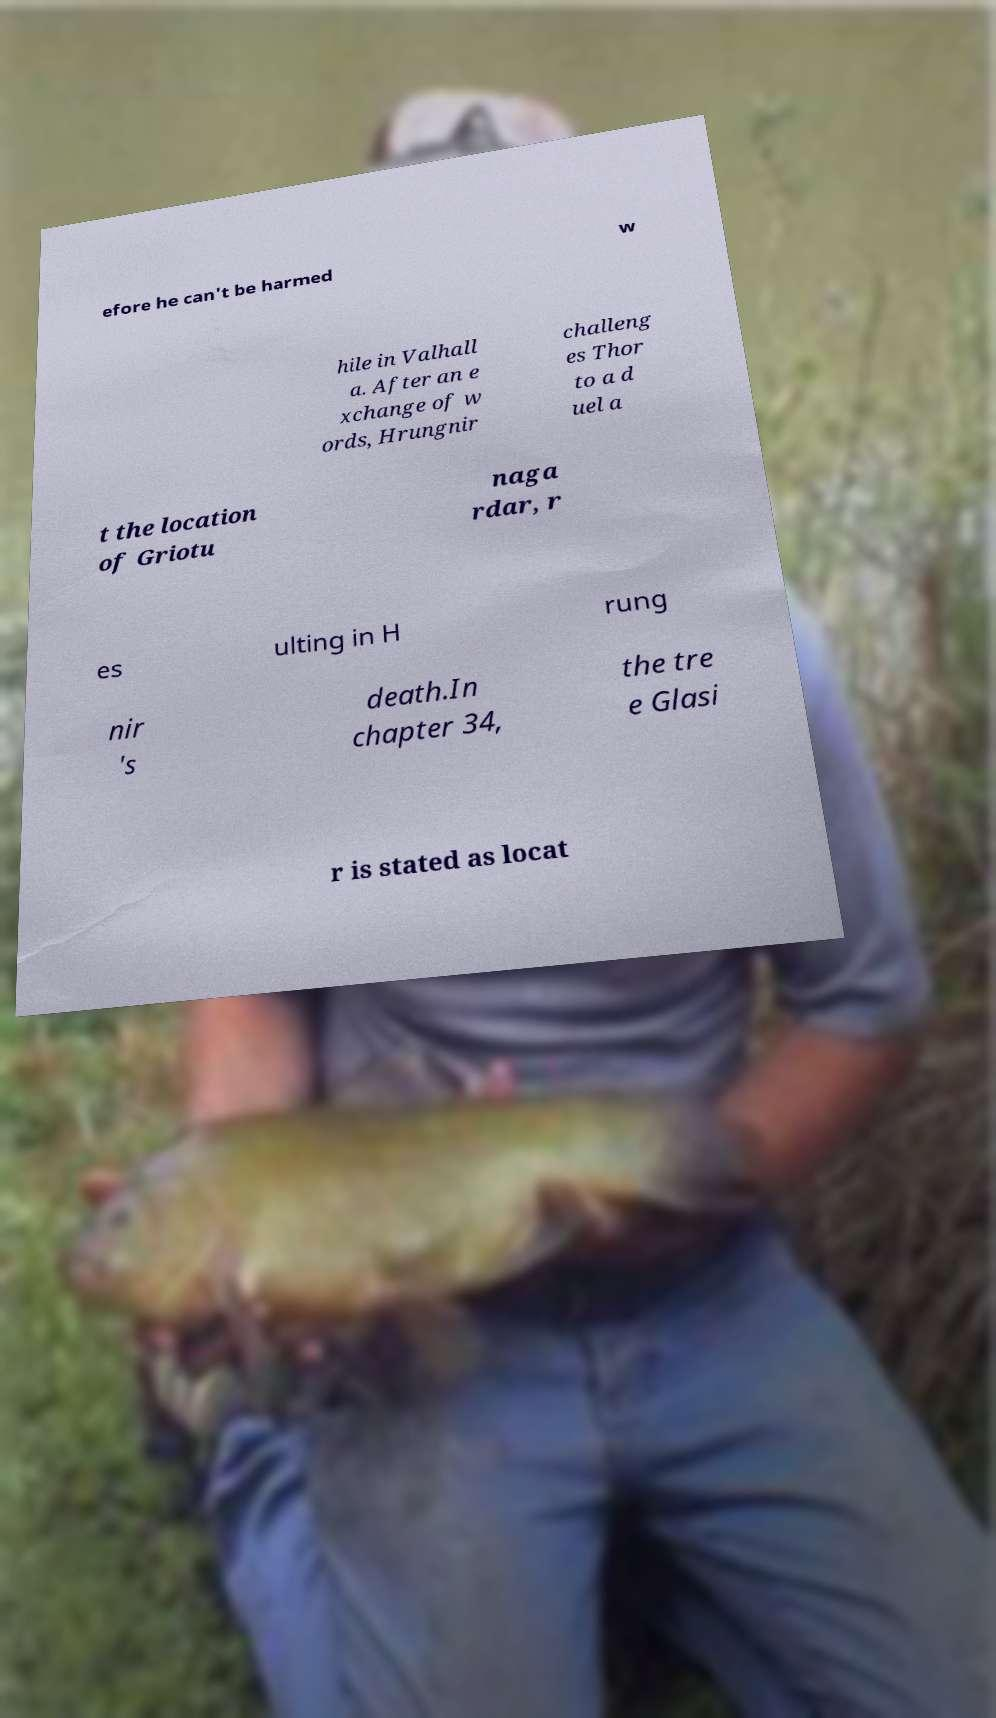What messages or text are displayed in this image? I need them in a readable, typed format. efore he can't be harmed w hile in Valhall a. After an e xchange of w ords, Hrungnir challeng es Thor to a d uel a t the location of Griotu naga rdar, r es ulting in H rung nir 's death.In chapter 34, the tre e Glasi r is stated as locat 